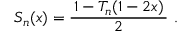<formula> <loc_0><loc_0><loc_500><loc_500>S _ { n } ( x ) = { \frac { \, 1 - T _ { n } ( 1 - 2 x ) \, } { 2 } } .</formula> 